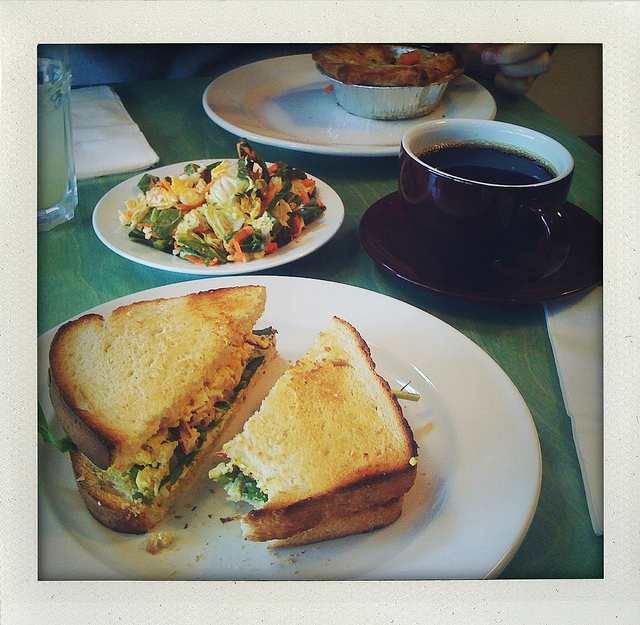<image>What is the design on the platter to the rear? I can't tell what the design on the platter to the rear is. It could be solid white, circle or none. What vegetable is in the dish in the back? I am not sure what vegetable is in the dish in the back. It could be salad, carrot, lettuce, broccoli or root vegetables. What kind of design is on the table cloth? The design on the table cloth is unknown. It could be floral, embroidery, solid, marbled, green, damask, swirl, or there could be no design at all. What vegetable is in the dish in the back? I am not sure what vegetable is in the dish in the back. It can be seen salad, carrot, or lettuce. What is the design on the platter to the rear? I am not sure what is the design on the platter to the rear. It can be seen as 'solid white', 'circle', 'no design', 'solid', 'plain white', or 'none'. What kind of design is on the table cloth? I don't know what kind of design is on the table cloth. It can be floral, embroidery, solid, marbled, or none. 